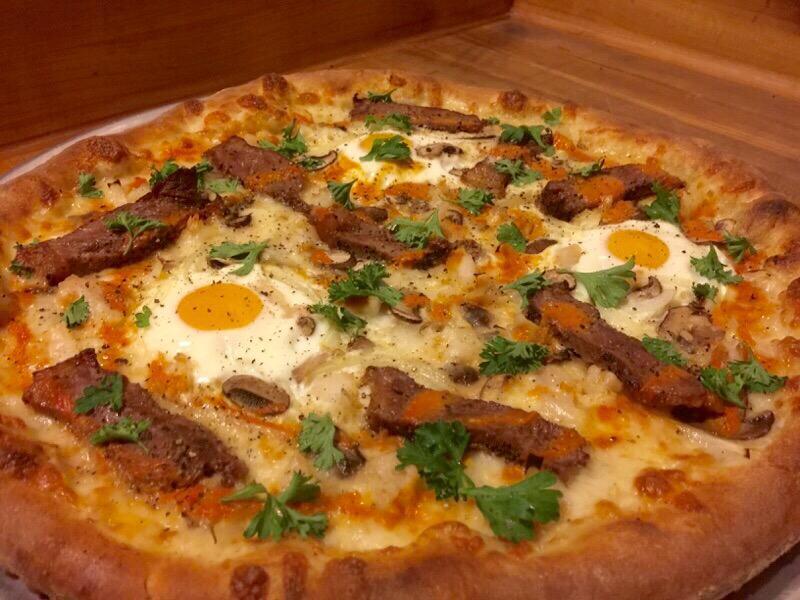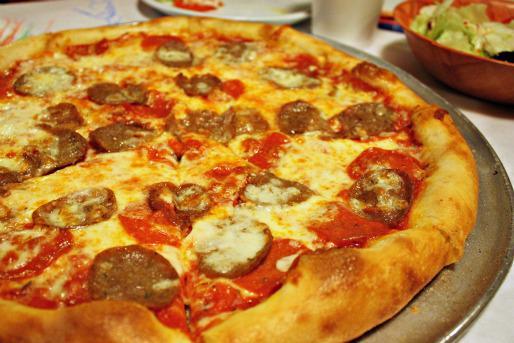The first image is the image on the left, the second image is the image on the right. Evaluate the accuracy of this statement regarding the images: "The pizza in one of the images is placed on a metal baking pan.". Is it true? Answer yes or no. Yes. 